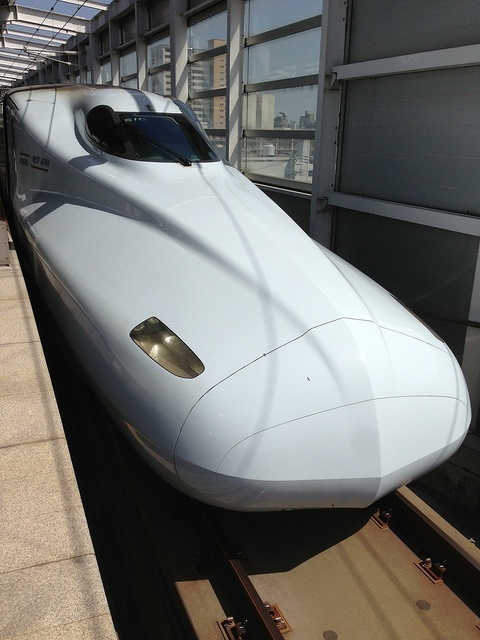Describe the objects in this image and their specific colors. I can see a train in black, lightgray, darkgray, and gray tones in this image. 